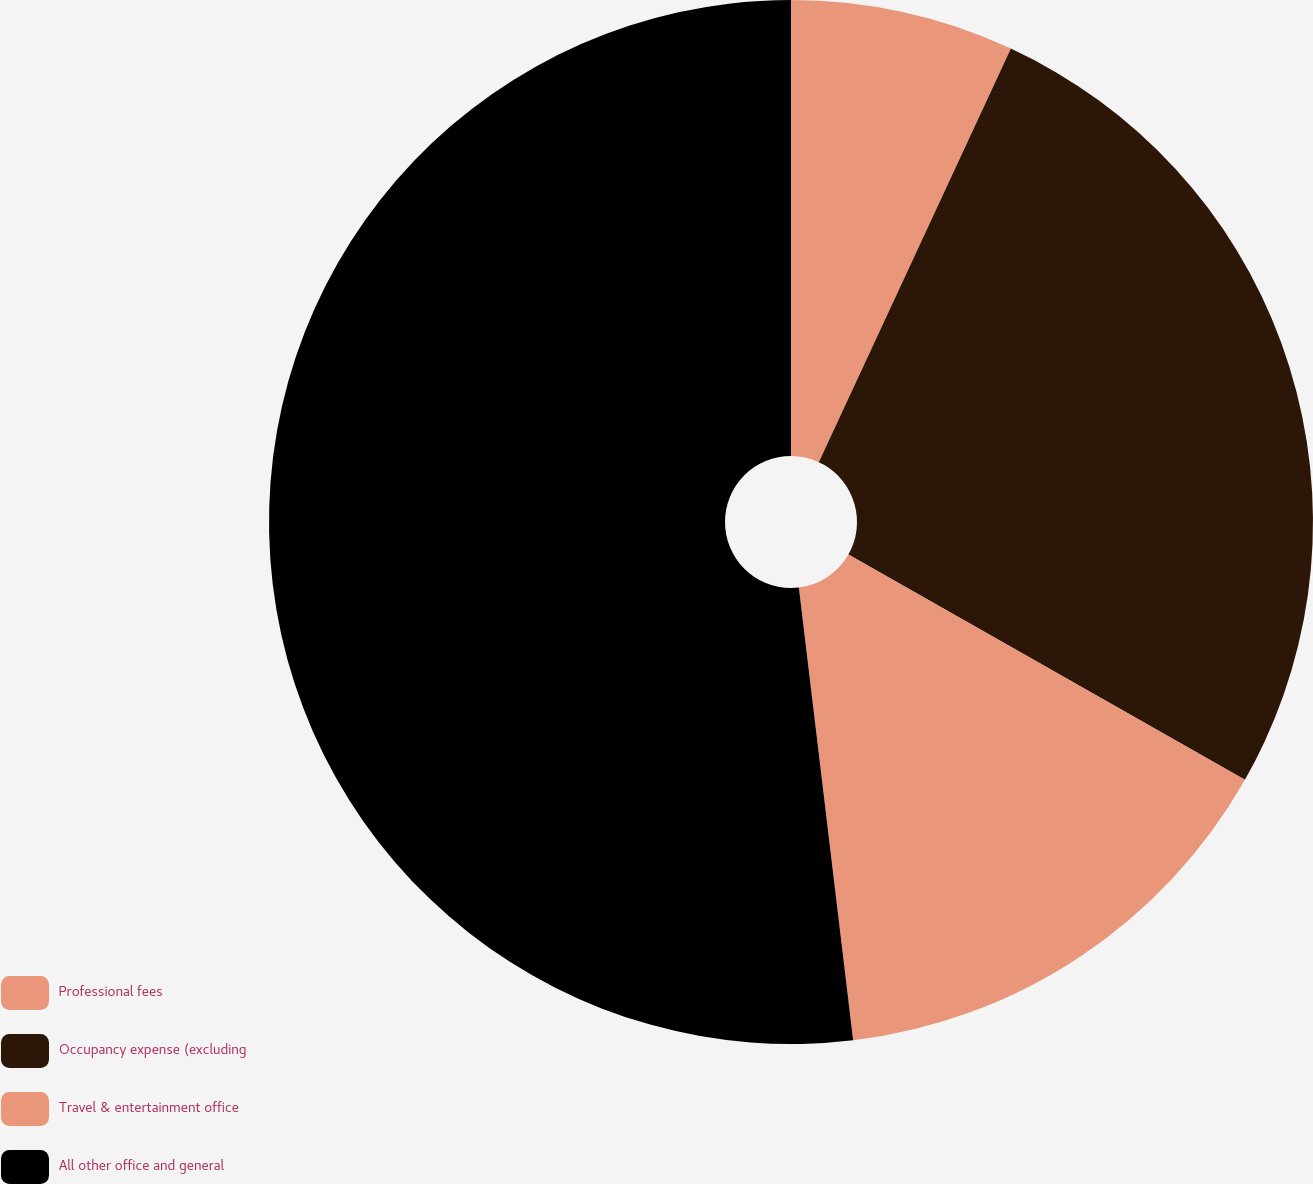Convert chart. <chart><loc_0><loc_0><loc_500><loc_500><pie_chart><fcel>Professional fees<fcel>Occupancy expense (excluding<fcel>Travel & entertainment office<fcel>All other office and general<nl><fcel>6.92%<fcel>26.3%<fcel>14.88%<fcel>51.9%<nl></chart> 